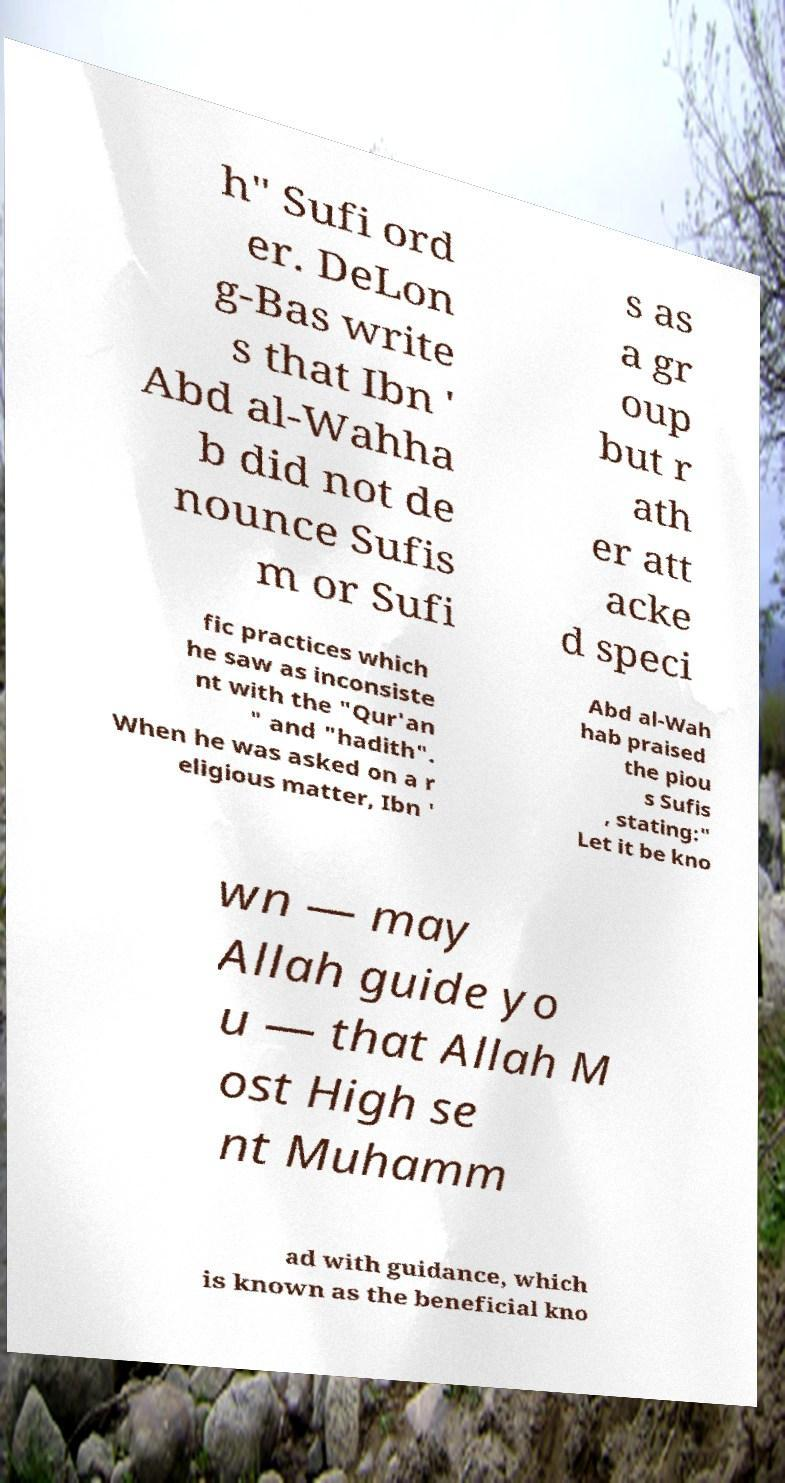For documentation purposes, I need the text within this image transcribed. Could you provide that? h" Sufi ord er. DeLon g-Bas write s that Ibn ' Abd al-Wahha b did not de nounce Sufis m or Sufi s as a gr oup but r ath er att acke d speci fic practices which he saw as inconsiste nt with the "Qur'an " and "hadith". When he was asked on a r eligious matter, Ibn ' Abd al-Wah hab praised the piou s Sufis , stating:" Let it be kno wn — may Allah guide yo u — that Allah M ost High se nt Muhamm ad with guidance, which is known as the beneficial kno 